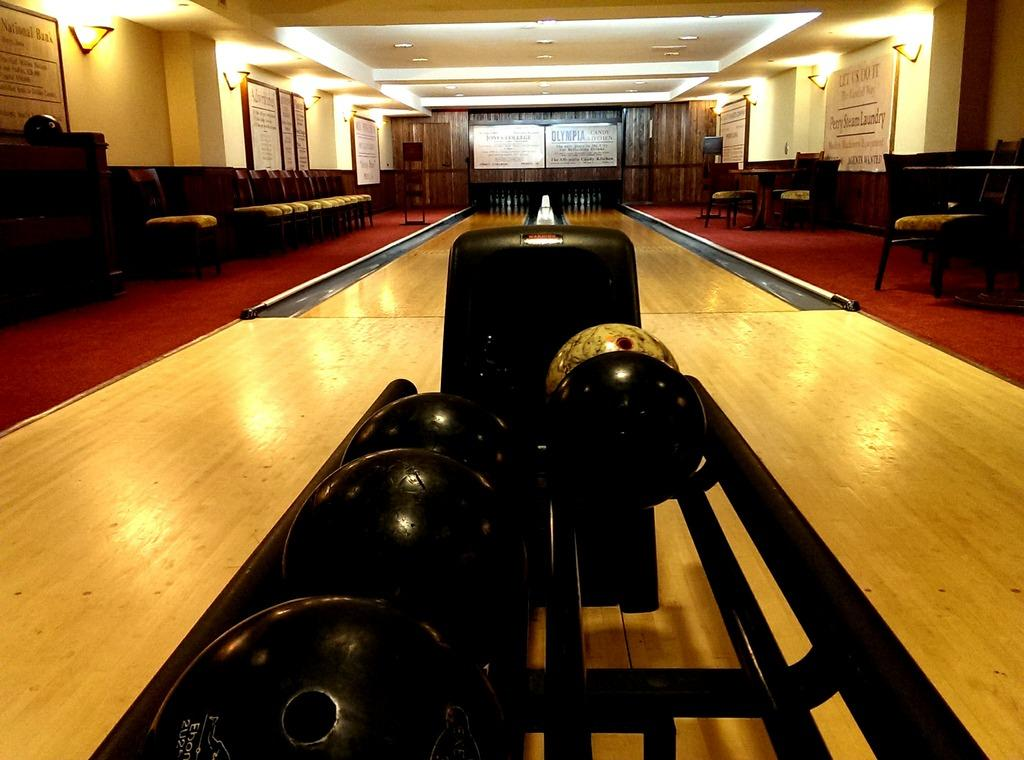What objects can be seen in the image? There are balls, chairs, and a table in the image. What is the floor made of? The floor is wooden. What is attached to the wall? There are boards and lights on the wall. What color is the carpet in the image? There is a red carpet in the image. What type of bird can be seen flying over the table in the image? There are no birds present in the image; it only features balls, chairs, a table, and a red carpet. 